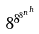Convert formula to latex. <formula><loc_0><loc_0><loc_500><loc_500>8 ^ { 8 ^ { 8 ^ { n ^ { h } } } }</formula> 